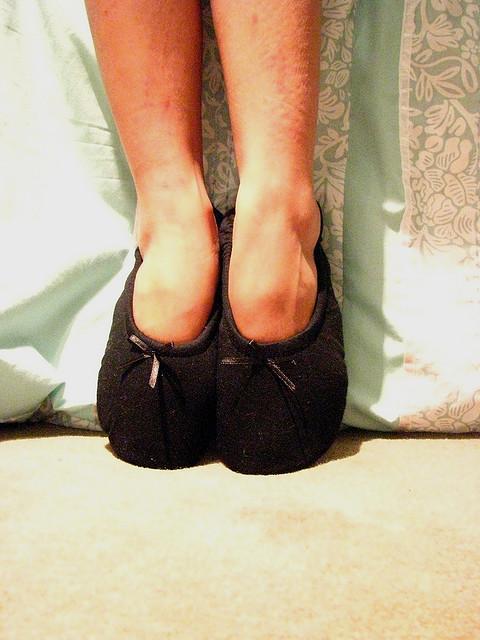Are those ballet shoes?
Give a very brief answer. No. What are those called on the feet?
Give a very brief answer. Slippers. Could this be a bedroom?
Answer briefly. Yes. 